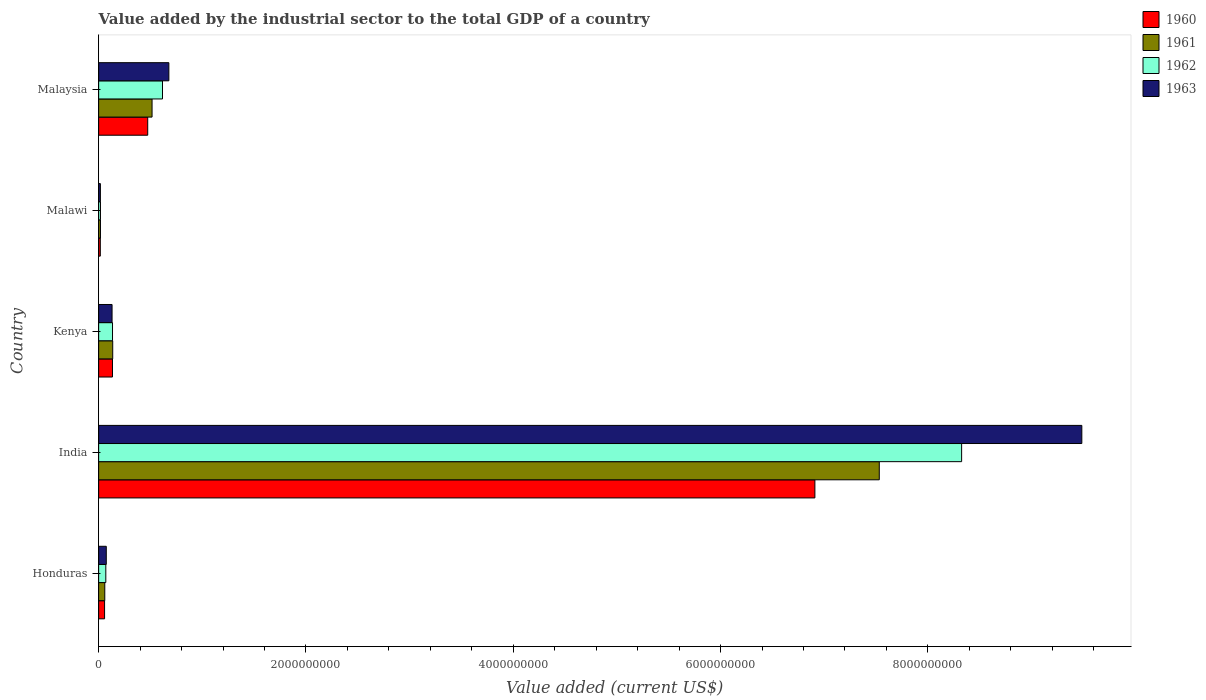How many different coloured bars are there?
Make the answer very short. 4. How many groups of bars are there?
Offer a very short reply. 5. How many bars are there on the 1st tick from the bottom?
Give a very brief answer. 4. What is the label of the 3rd group of bars from the top?
Your response must be concise. Kenya. What is the value added by the industrial sector to the total GDP in 1961 in India?
Your answer should be very brief. 7.53e+09. Across all countries, what is the maximum value added by the industrial sector to the total GDP in 1962?
Provide a succinct answer. 8.33e+09. Across all countries, what is the minimum value added by the industrial sector to the total GDP in 1960?
Make the answer very short. 1.62e+07. In which country was the value added by the industrial sector to the total GDP in 1962 minimum?
Offer a terse response. Malawi. What is the total value added by the industrial sector to the total GDP in 1962 in the graph?
Give a very brief answer. 9.16e+09. What is the difference between the value added by the industrial sector to the total GDP in 1962 in India and that in Kenya?
Offer a very short reply. 8.19e+09. What is the difference between the value added by the industrial sector to the total GDP in 1962 in India and the value added by the industrial sector to the total GDP in 1960 in Malawi?
Offer a very short reply. 8.31e+09. What is the average value added by the industrial sector to the total GDP in 1960 per country?
Give a very brief answer. 1.52e+09. What is the difference between the value added by the industrial sector to the total GDP in 1963 and value added by the industrial sector to the total GDP in 1961 in Honduras?
Ensure brevity in your answer.  1.44e+07. In how many countries, is the value added by the industrial sector to the total GDP in 1961 greater than 6000000000 US$?
Keep it short and to the point. 1. What is the ratio of the value added by the industrial sector to the total GDP in 1961 in Kenya to that in Malaysia?
Provide a succinct answer. 0.26. Is the value added by the industrial sector to the total GDP in 1962 in Honduras less than that in India?
Provide a short and direct response. Yes. Is the difference between the value added by the industrial sector to the total GDP in 1963 in Honduras and Malaysia greater than the difference between the value added by the industrial sector to the total GDP in 1961 in Honduras and Malaysia?
Your response must be concise. No. What is the difference between the highest and the second highest value added by the industrial sector to the total GDP in 1960?
Your response must be concise. 6.44e+09. What is the difference between the highest and the lowest value added by the industrial sector to the total GDP in 1963?
Offer a very short reply. 9.47e+09. What does the 4th bar from the bottom in Malaysia represents?
Offer a terse response. 1963. How many countries are there in the graph?
Ensure brevity in your answer.  5. Are the values on the major ticks of X-axis written in scientific E-notation?
Your answer should be very brief. No. Does the graph contain any zero values?
Provide a short and direct response. No. Does the graph contain grids?
Ensure brevity in your answer.  No. Where does the legend appear in the graph?
Make the answer very short. Top right. How many legend labels are there?
Provide a succinct answer. 4. How are the legend labels stacked?
Offer a terse response. Vertical. What is the title of the graph?
Make the answer very short. Value added by the industrial sector to the total GDP of a country. Does "2001" appear as one of the legend labels in the graph?
Offer a very short reply. No. What is the label or title of the X-axis?
Your response must be concise. Value added (current US$). What is the label or title of the Y-axis?
Provide a short and direct response. Country. What is the Value added (current US$) of 1960 in Honduras?
Ensure brevity in your answer.  5.73e+07. What is the Value added (current US$) of 1961 in Honduras?
Your answer should be compact. 5.94e+07. What is the Value added (current US$) of 1962 in Honduras?
Provide a short and direct response. 6.92e+07. What is the Value added (current US$) in 1963 in Honduras?
Offer a very short reply. 7.38e+07. What is the Value added (current US$) in 1960 in India?
Offer a terse response. 6.91e+09. What is the Value added (current US$) of 1961 in India?
Offer a terse response. 7.53e+09. What is the Value added (current US$) in 1962 in India?
Provide a succinct answer. 8.33e+09. What is the Value added (current US$) in 1963 in India?
Your response must be concise. 9.49e+09. What is the Value added (current US$) of 1960 in Kenya?
Ensure brevity in your answer.  1.34e+08. What is the Value added (current US$) in 1961 in Kenya?
Your response must be concise. 1.36e+08. What is the Value added (current US$) in 1962 in Kenya?
Keep it short and to the point. 1.34e+08. What is the Value added (current US$) of 1963 in Kenya?
Provide a succinct answer. 1.30e+08. What is the Value added (current US$) of 1960 in Malawi?
Your answer should be compact. 1.62e+07. What is the Value added (current US$) of 1961 in Malawi?
Provide a succinct answer. 1.76e+07. What is the Value added (current US$) of 1962 in Malawi?
Provide a succinct answer. 1.78e+07. What is the Value added (current US$) in 1963 in Malawi?
Your answer should be compact. 1.69e+07. What is the Value added (current US$) of 1960 in Malaysia?
Your answer should be very brief. 4.74e+08. What is the Value added (current US$) in 1961 in Malaysia?
Offer a very short reply. 5.15e+08. What is the Value added (current US$) in 1962 in Malaysia?
Ensure brevity in your answer.  6.16e+08. What is the Value added (current US$) in 1963 in Malaysia?
Ensure brevity in your answer.  6.77e+08. Across all countries, what is the maximum Value added (current US$) of 1960?
Ensure brevity in your answer.  6.91e+09. Across all countries, what is the maximum Value added (current US$) in 1961?
Your answer should be very brief. 7.53e+09. Across all countries, what is the maximum Value added (current US$) in 1962?
Make the answer very short. 8.33e+09. Across all countries, what is the maximum Value added (current US$) of 1963?
Your answer should be very brief. 9.49e+09. Across all countries, what is the minimum Value added (current US$) of 1960?
Provide a succinct answer. 1.62e+07. Across all countries, what is the minimum Value added (current US$) in 1961?
Your response must be concise. 1.76e+07. Across all countries, what is the minimum Value added (current US$) in 1962?
Provide a succinct answer. 1.78e+07. Across all countries, what is the minimum Value added (current US$) of 1963?
Your answer should be very brief. 1.69e+07. What is the total Value added (current US$) in 1960 in the graph?
Offer a terse response. 7.59e+09. What is the total Value added (current US$) in 1961 in the graph?
Ensure brevity in your answer.  8.26e+09. What is the total Value added (current US$) in 1962 in the graph?
Provide a succinct answer. 9.16e+09. What is the total Value added (current US$) of 1963 in the graph?
Provide a short and direct response. 1.04e+1. What is the difference between the Value added (current US$) in 1960 in Honduras and that in India?
Your answer should be compact. -6.85e+09. What is the difference between the Value added (current US$) of 1961 in Honduras and that in India?
Your response must be concise. -7.47e+09. What is the difference between the Value added (current US$) in 1962 in Honduras and that in India?
Keep it short and to the point. -8.26e+09. What is the difference between the Value added (current US$) in 1963 in Honduras and that in India?
Your answer should be very brief. -9.41e+09. What is the difference between the Value added (current US$) in 1960 in Honduras and that in Kenya?
Give a very brief answer. -7.63e+07. What is the difference between the Value added (current US$) of 1961 in Honduras and that in Kenya?
Your answer should be compact. -7.65e+07. What is the difference between the Value added (current US$) of 1962 in Honduras and that in Kenya?
Offer a very short reply. -6.47e+07. What is the difference between the Value added (current US$) of 1963 in Honduras and that in Kenya?
Provide a short and direct response. -5.57e+07. What is the difference between the Value added (current US$) in 1960 in Honduras and that in Malawi?
Offer a very short reply. 4.11e+07. What is the difference between the Value added (current US$) in 1961 in Honduras and that in Malawi?
Your response must be concise. 4.17e+07. What is the difference between the Value added (current US$) of 1962 in Honduras and that in Malawi?
Provide a short and direct response. 5.14e+07. What is the difference between the Value added (current US$) in 1963 in Honduras and that in Malawi?
Offer a terse response. 5.69e+07. What is the difference between the Value added (current US$) of 1960 in Honduras and that in Malaysia?
Keep it short and to the point. -4.16e+08. What is the difference between the Value added (current US$) of 1961 in Honduras and that in Malaysia?
Give a very brief answer. -4.56e+08. What is the difference between the Value added (current US$) of 1962 in Honduras and that in Malaysia?
Ensure brevity in your answer.  -5.47e+08. What is the difference between the Value added (current US$) in 1963 in Honduras and that in Malaysia?
Provide a short and direct response. -6.04e+08. What is the difference between the Value added (current US$) of 1960 in India and that in Kenya?
Keep it short and to the point. 6.78e+09. What is the difference between the Value added (current US$) of 1961 in India and that in Kenya?
Provide a succinct answer. 7.40e+09. What is the difference between the Value added (current US$) of 1962 in India and that in Kenya?
Offer a very short reply. 8.19e+09. What is the difference between the Value added (current US$) of 1963 in India and that in Kenya?
Offer a terse response. 9.36e+09. What is the difference between the Value added (current US$) of 1960 in India and that in Malawi?
Give a very brief answer. 6.89e+09. What is the difference between the Value added (current US$) of 1961 in India and that in Malawi?
Give a very brief answer. 7.51e+09. What is the difference between the Value added (current US$) of 1962 in India and that in Malawi?
Your answer should be compact. 8.31e+09. What is the difference between the Value added (current US$) in 1963 in India and that in Malawi?
Ensure brevity in your answer.  9.47e+09. What is the difference between the Value added (current US$) of 1960 in India and that in Malaysia?
Provide a succinct answer. 6.44e+09. What is the difference between the Value added (current US$) in 1961 in India and that in Malaysia?
Provide a succinct answer. 7.02e+09. What is the difference between the Value added (current US$) in 1962 in India and that in Malaysia?
Offer a very short reply. 7.71e+09. What is the difference between the Value added (current US$) in 1963 in India and that in Malaysia?
Provide a succinct answer. 8.81e+09. What is the difference between the Value added (current US$) of 1960 in Kenya and that in Malawi?
Ensure brevity in your answer.  1.17e+08. What is the difference between the Value added (current US$) in 1961 in Kenya and that in Malawi?
Make the answer very short. 1.18e+08. What is the difference between the Value added (current US$) of 1962 in Kenya and that in Malawi?
Ensure brevity in your answer.  1.16e+08. What is the difference between the Value added (current US$) in 1963 in Kenya and that in Malawi?
Provide a succinct answer. 1.13e+08. What is the difference between the Value added (current US$) of 1960 in Kenya and that in Malaysia?
Offer a terse response. -3.40e+08. What is the difference between the Value added (current US$) of 1961 in Kenya and that in Malaysia?
Provide a succinct answer. -3.79e+08. What is the difference between the Value added (current US$) in 1962 in Kenya and that in Malaysia?
Ensure brevity in your answer.  -4.82e+08. What is the difference between the Value added (current US$) in 1963 in Kenya and that in Malaysia?
Offer a very short reply. -5.48e+08. What is the difference between the Value added (current US$) in 1960 in Malawi and that in Malaysia?
Your answer should be compact. -4.57e+08. What is the difference between the Value added (current US$) in 1961 in Malawi and that in Malaysia?
Keep it short and to the point. -4.98e+08. What is the difference between the Value added (current US$) in 1962 in Malawi and that in Malaysia?
Provide a short and direct response. -5.98e+08. What is the difference between the Value added (current US$) in 1963 in Malawi and that in Malaysia?
Your answer should be compact. -6.61e+08. What is the difference between the Value added (current US$) in 1960 in Honduras and the Value added (current US$) in 1961 in India?
Offer a very short reply. -7.47e+09. What is the difference between the Value added (current US$) in 1960 in Honduras and the Value added (current US$) in 1962 in India?
Your response must be concise. -8.27e+09. What is the difference between the Value added (current US$) of 1960 in Honduras and the Value added (current US$) of 1963 in India?
Offer a very short reply. -9.43e+09. What is the difference between the Value added (current US$) of 1961 in Honduras and the Value added (current US$) of 1962 in India?
Your response must be concise. -8.27e+09. What is the difference between the Value added (current US$) of 1961 in Honduras and the Value added (current US$) of 1963 in India?
Your answer should be compact. -9.43e+09. What is the difference between the Value added (current US$) of 1962 in Honduras and the Value added (current US$) of 1963 in India?
Provide a succinct answer. -9.42e+09. What is the difference between the Value added (current US$) of 1960 in Honduras and the Value added (current US$) of 1961 in Kenya?
Your answer should be compact. -7.86e+07. What is the difference between the Value added (current US$) of 1960 in Honduras and the Value added (current US$) of 1962 in Kenya?
Make the answer very short. -7.66e+07. What is the difference between the Value added (current US$) of 1960 in Honduras and the Value added (current US$) of 1963 in Kenya?
Make the answer very short. -7.22e+07. What is the difference between the Value added (current US$) of 1961 in Honduras and the Value added (current US$) of 1962 in Kenya?
Keep it short and to the point. -7.46e+07. What is the difference between the Value added (current US$) of 1961 in Honduras and the Value added (current US$) of 1963 in Kenya?
Ensure brevity in your answer.  -7.02e+07. What is the difference between the Value added (current US$) in 1962 in Honduras and the Value added (current US$) in 1963 in Kenya?
Your answer should be very brief. -6.03e+07. What is the difference between the Value added (current US$) in 1960 in Honduras and the Value added (current US$) in 1961 in Malawi?
Your response must be concise. 3.97e+07. What is the difference between the Value added (current US$) of 1960 in Honduras and the Value added (current US$) of 1962 in Malawi?
Provide a succinct answer. 3.95e+07. What is the difference between the Value added (current US$) of 1960 in Honduras and the Value added (current US$) of 1963 in Malawi?
Your answer should be compact. 4.04e+07. What is the difference between the Value added (current US$) of 1961 in Honduras and the Value added (current US$) of 1962 in Malawi?
Keep it short and to the point. 4.16e+07. What is the difference between the Value added (current US$) in 1961 in Honduras and the Value added (current US$) in 1963 in Malawi?
Your response must be concise. 4.24e+07. What is the difference between the Value added (current US$) in 1962 in Honduras and the Value added (current US$) in 1963 in Malawi?
Your answer should be compact. 5.23e+07. What is the difference between the Value added (current US$) of 1960 in Honduras and the Value added (current US$) of 1961 in Malaysia?
Ensure brevity in your answer.  -4.58e+08. What is the difference between the Value added (current US$) in 1960 in Honduras and the Value added (current US$) in 1962 in Malaysia?
Your answer should be very brief. -5.59e+08. What is the difference between the Value added (current US$) of 1960 in Honduras and the Value added (current US$) of 1963 in Malaysia?
Offer a very short reply. -6.20e+08. What is the difference between the Value added (current US$) of 1961 in Honduras and the Value added (current US$) of 1962 in Malaysia?
Keep it short and to the point. -5.57e+08. What is the difference between the Value added (current US$) in 1961 in Honduras and the Value added (current US$) in 1963 in Malaysia?
Offer a very short reply. -6.18e+08. What is the difference between the Value added (current US$) of 1962 in Honduras and the Value added (current US$) of 1963 in Malaysia?
Provide a short and direct response. -6.08e+08. What is the difference between the Value added (current US$) in 1960 in India and the Value added (current US$) in 1961 in Kenya?
Your answer should be compact. 6.77e+09. What is the difference between the Value added (current US$) in 1960 in India and the Value added (current US$) in 1962 in Kenya?
Keep it short and to the point. 6.78e+09. What is the difference between the Value added (current US$) of 1960 in India and the Value added (current US$) of 1963 in Kenya?
Make the answer very short. 6.78e+09. What is the difference between the Value added (current US$) in 1961 in India and the Value added (current US$) in 1962 in Kenya?
Provide a succinct answer. 7.40e+09. What is the difference between the Value added (current US$) in 1961 in India and the Value added (current US$) in 1963 in Kenya?
Keep it short and to the point. 7.40e+09. What is the difference between the Value added (current US$) in 1962 in India and the Value added (current US$) in 1963 in Kenya?
Keep it short and to the point. 8.20e+09. What is the difference between the Value added (current US$) in 1960 in India and the Value added (current US$) in 1961 in Malawi?
Offer a very short reply. 6.89e+09. What is the difference between the Value added (current US$) of 1960 in India and the Value added (current US$) of 1962 in Malawi?
Your response must be concise. 6.89e+09. What is the difference between the Value added (current US$) in 1960 in India and the Value added (current US$) in 1963 in Malawi?
Provide a short and direct response. 6.89e+09. What is the difference between the Value added (current US$) in 1961 in India and the Value added (current US$) in 1962 in Malawi?
Your answer should be compact. 7.51e+09. What is the difference between the Value added (current US$) of 1961 in India and the Value added (current US$) of 1963 in Malawi?
Your answer should be very brief. 7.51e+09. What is the difference between the Value added (current US$) in 1962 in India and the Value added (current US$) in 1963 in Malawi?
Your answer should be compact. 8.31e+09. What is the difference between the Value added (current US$) in 1960 in India and the Value added (current US$) in 1961 in Malaysia?
Keep it short and to the point. 6.39e+09. What is the difference between the Value added (current US$) in 1960 in India and the Value added (current US$) in 1962 in Malaysia?
Keep it short and to the point. 6.29e+09. What is the difference between the Value added (current US$) in 1960 in India and the Value added (current US$) in 1963 in Malaysia?
Provide a succinct answer. 6.23e+09. What is the difference between the Value added (current US$) in 1961 in India and the Value added (current US$) in 1962 in Malaysia?
Make the answer very short. 6.92e+09. What is the difference between the Value added (current US$) of 1961 in India and the Value added (current US$) of 1963 in Malaysia?
Ensure brevity in your answer.  6.85e+09. What is the difference between the Value added (current US$) of 1962 in India and the Value added (current US$) of 1963 in Malaysia?
Your answer should be very brief. 7.65e+09. What is the difference between the Value added (current US$) in 1960 in Kenya and the Value added (current US$) in 1961 in Malawi?
Make the answer very short. 1.16e+08. What is the difference between the Value added (current US$) in 1960 in Kenya and the Value added (current US$) in 1962 in Malawi?
Your answer should be compact. 1.16e+08. What is the difference between the Value added (current US$) in 1960 in Kenya and the Value added (current US$) in 1963 in Malawi?
Give a very brief answer. 1.17e+08. What is the difference between the Value added (current US$) in 1961 in Kenya and the Value added (current US$) in 1962 in Malawi?
Your answer should be very brief. 1.18e+08. What is the difference between the Value added (current US$) in 1961 in Kenya and the Value added (current US$) in 1963 in Malawi?
Ensure brevity in your answer.  1.19e+08. What is the difference between the Value added (current US$) of 1962 in Kenya and the Value added (current US$) of 1963 in Malawi?
Keep it short and to the point. 1.17e+08. What is the difference between the Value added (current US$) in 1960 in Kenya and the Value added (current US$) in 1961 in Malaysia?
Your answer should be compact. -3.82e+08. What is the difference between the Value added (current US$) of 1960 in Kenya and the Value added (current US$) of 1962 in Malaysia?
Ensure brevity in your answer.  -4.82e+08. What is the difference between the Value added (current US$) in 1960 in Kenya and the Value added (current US$) in 1963 in Malaysia?
Offer a very short reply. -5.44e+08. What is the difference between the Value added (current US$) in 1961 in Kenya and the Value added (current US$) in 1962 in Malaysia?
Give a very brief answer. -4.80e+08. What is the difference between the Value added (current US$) in 1961 in Kenya and the Value added (current US$) in 1963 in Malaysia?
Offer a terse response. -5.42e+08. What is the difference between the Value added (current US$) in 1962 in Kenya and the Value added (current US$) in 1963 in Malaysia?
Give a very brief answer. -5.44e+08. What is the difference between the Value added (current US$) of 1960 in Malawi and the Value added (current US$) of 1961 in Malaysia?
Provide a short and direct response. -4.99e+08. What is the difference between the Value added (current US$) of 1960 in Malawi and the Value added (current US$) of 1962 in Malaysia?
Your answer should be compact. -6.00e+08. What is the difference between the Value added (current US$) of 1960 in Malawi and the Value added (current US$) of 1963 in Malaysia?
Ensure brevity in your answer.  -6.61e+08. What is the difference between the Value added (current US$) of 1961 in Malawi and the Value added (current US$) of 1962 in Malaysia?
Keep it short and to the point. -5.98e+08. What is the difference between the Value added (current US$) of 1961 in Malawi and the Value added (current US$) of 1963 in Malaysia?
Provide a succinct answer. -6.60e+08. What is the difference between the Value added (current US$) of 1962 in Malawi and the Value added (current US$) of 1963 in Malaysia?
Give a very brief answer. -6.60e+08. What is the average Value added (current US$) in 1960 per country?
Your response must be concise. 1.52e+09. What is the average Value added (current US$) in 1961 per country?
Your answer should be very brief. 1.65e+09. What is the average Value added (current US$) in 1962 per country?
Your response must be concise. 1.83e+09. What is the average Value added (current US$) of 1963 per country?
Your answer should be compact. 2.08e+09. What is the difference between the Value added (current US$) in 1960 and Value added (current US$) in 1961 in Honduras?
Offer a terse response. -2.05e+06. What is the difference between the Value added (current US$) in 1960 and Value added (current US$) in 1962 in Honduras?
Keep it short and to the point. -1.19e+07. What is the difference between the Value added (current US$) of 1960 and Value added (current US$) of 1963 in Honduras?
Offer a terse response. -1.65e+07. What is the difference between the Value added (current US$) in 1961 and Value added (current US$) in 1962 in Honduras?
Your answer should be compact. -9.85e+06. What is the difference between the Value added (current US$) of 1961 and Value added (current US$) of 1963 in Honduras?
Provide a short and direct response. -1.44e+07. What is the difference between the Value added (current US$) in 1962 and Value added (current US$) in 1963 in Honduras?
Offer a terse response. -4.60e+06. What is the difference between the Value added (current US$) of 1960 and Value added (current US$) of 1961 in India?
Give a very brief answer. -6.21e+08. What is the difference between the Value added (current US$) in 1960 and Value added (current US$) in 1962 in India?
Your response must be concise. -1.42e+09. What is the difference between the Value added (current US$) of 1960 and Value added (current US$) of 1963 in India?
Your response must be concise. -2.58e+09. What is the difference between the Value added (current US$) of 1961 and Value added (current US$) of 1962 in India?
Your response must be concise. -7.94e+08. What is the difference between the Value added (current US$) in 1961 and Value added (current US$) in 1963 in India?
Give a very brief answer. -1.95e+09. What is the difference between the Value added (current US$) of 1962 and Value added (current US$) of 1963 in India?
Provide a succinct answer. -1.16e+09. What is the difference between the Value added (current US$) in 1960 and Value added (current US$) in 1961 in Kenya?
Your answer should be compact. -2.25e+06. What is the difference between the Value added (current US$) of 1960 and Value added (current US$) of 1962 in Kenya?
Ensure brevity in your answer.  -2.94e+05. What is the difference between the Value added (current US$) in 1960 and Value added (current US$) in 1963 in Kenya?
Give a very brief answer. 4.12e+06. What is the difference between the Value added (current US$) in 1961 and Value added (current US$) in 1962 in Kenya?
Provide a succinct answer. 1.96e+06. What is the difference between the Value added (current US$) of 1961 and Value added (current US$) of 1963 in Kenya?
Your answer should be compact. 6.37e+06. What is the difference between the Value added (current US$) in 1962 and Value added (current US$) in 1963 in Kenya?
Keep it short and to the point. 4.41e+06. What is the difference between the Value added (current US$) of 1960 and Value added (current US$) of 1961 in Malawi?
Offer a terse response. -1.40e+06. What is the difference between the Value added (current US$) of 1960 and Value added (current US$) of 1962 in Malawi?
Give a very brief answer. -1.54e+06. What is the difference between the Value added (current US$) in 1960 and Value added (current US$) in 1963 in Malawi?
Make the answer very short. -7.00e+05. What is the difference between the Value added (current US$) in 1961 and Value added (current US$) in 1962 in Malawi?
Make the answer very short. -1.40e+05. What is the difference between the Value added (current US$) of 1961 and Value added (current US$) of 1963 in Malawi?
Offer a very short reply. 7.00e+05. What is the difference between the Value added (current US$) in 1962 and Value added (current US$) in 1963 in Malawi?
Provide a succinct answer. 8.40e+05. What is the difference between the Value added (current US$) in 1960 and Value added (current US$) in 1961 in Malaysia?
Offer a very short reply. -4.19e+07. What is the difference between the Value added (current US$) in 1960 and Value added (current US$) in 1962 in Malaysia?
Provide a succinct answer. -1.43e+08. What is the difference between the Value added (current US$) of 1960 and Value added (current US$) of 1963 in Malaysia?
Provide a short and direct response. -2.04e+08. What is the difference between the Value added (current US$) in 1961 and Value added (current US$) in 1962 in Malaysia?
Ensure brevity in your answer.  -1.01e+08. What is the difference between the Value added (current US$) of 1961 and Value added (current US$) of 1963 in Malaysia?
Your answer should be very brief. -1.62e+08. What is the difference between the Value added (current US$) in 1962 and Value added (current US$) in 1963 in Malaysia?
Your answer should be compact. -6.14e+07. What is the ratio of the Value added (current US$) in 1960 in Honduras to that in India?
Keep it short and to the point. 0.01. What is the ratio of the Value added (current US$) in 1961 in Honduras to that in India?
Give a very brief answer. 0.01. What is the ratio of the Value added (current US$) in 1962 in Honduras to that in India?
Make the answer very short. 0.01. What is the ratio of the Value added (current US$) in 1963 in Honduras to that in India?
Your answer should be compact. 0.01. What is the ratio of the Value added (current US$) of 1960 in Honduras to that in Kenya?
Offer a terse response. 0.43. What is the ratio of the Value added (current US$) in 1961 in Honduras to that in Kenya?
Your response must be concise. 0.44. What is the ratio of the Value added (current US$) in 1962 in Honduras to that in Kenya?
Give a very brief answer. 0.52. What is the ratio of the Value added (current US$) of 1963 in Honduras to that in Kenya?
Your response must be concise. 0.57. What is the ratio of the Value added (current US$) in 1960 in Honduras to that in Malawi?
Offer a very short reply. 3.53. What is the ratio of the Value added (current US$) in 1961 in Honduras to that in Malawi?
Offer a terse response. 3.36. What is the ratio of the Value added (current US$) of 1962 in Honduras to that in Malawi?
Offer a terse response. 3.89. What is the ratio of the Value added (current US$) in 1963 in Honduras to that in Malawi?
Keep it short and to the point. 4.36. What is the ratio of the Value added (current US$) of 1960 in Honduras to that in Malaysia?
Make the answer very short. 0.12. What is the ratio of the Value added (current US$) in 1961 in Honduras to that in Malaysia?
Make the answer very short. 0.12. What is the ratio of the Value added (current US$) of 1962 in Honduras to that in Malaysia?
Keep it short and to the point. 0.11. What is the ratio of the Value added (current US$) in 1963 in Honduras to that in Malaysia?
Your response must be concise. 0.11. What is the ratio of the Value added (current US$) of 1960 in India to that in Kenya?
Offer a terse response. 51.7. What is the ratio of the Value added (current US$) in 1961 in India to that in Kenya?
Provide a short and direct response. 55.42. What is the ratio of the Value added (current US$) of 1962 in India to that in Kenya?
Offer a terse response. 62.16. What is the ratio of the Value added (current US$) of 1963 in India to that in Kenya?
Your answer should be very brief. 73.23. What is the ratio of the Value added (current US$) of 1960 in India to that in Malawi?
Provide a succinct answer. 425.49. What is the ratio of the Value added (current US$) in 1961 in India to that in Malawi?
Keep it short and to the point. 426.94. What is the ratio of the Value added (current US$) in 1962 in India to that in Malawi?
Provide a succinct answer. 468.26. What is the ratio of the Value added (current US$) in 1963 in India to that in Malawi?
Give a very brief answer. 559.94. What is the ratio of the Value added (current US$) of 1960 in India to that in Malaysia?
Your answer should be very brief. 14.59. What is the ratio of the Value added (current US$) of 1961 in India to that in Malaysia?
Your response must be concise. 14.61. What is the ratio of the Value added (current US$) in 1962 in India to that in Malaysia?
Provide a short and direct response. 13.51. What is the ratio of the Value added (current US$) of 1963 in India to that in Malaysia?
Your answer should be compact. 14. What is the ratio of the Value added (current US$) in 1960 in Kenya to that in Malawi?
Your answer should be very brief. 8.23. What is the ratio of the Value added (current US$) of 1961 in Kenya to that in Malawi?
Offer a very short reply. 7.7. What is the ratio of the Value added (current US$) in 1962 in Kenya to that in Malawi?
Offer a very short reply. 7.53. What is the ratio of the Value added (current US$) in 1963 in Kenya to that in Malawi?
Your response must be concise. 7.65. What is the ratio of the Value added (current US$) in 1960 in Kenya to that in Malaysia?
Make the answer very short. 0.28. What is the ratio of the Value added (current US$) of 1961 in Kenya to that in Malaysia?
Your answer should be very brief. 0.26. What is the ratio of the Value added (current US$) of 1962 in Kenya to that in Malaysia?
Provide a succinct answer. 0.22. What is the ratio of the Value added (current US$) of 1963 in Kenya to that in Malaysia?
Offer a terse response. 0.19. What is the ratio of the Value added (current US$) in 1960 in Malawi to that in Malaysia?
Your answer should be very brief. 0.03. What is the ratio of the Value added (current US$) in 1961 in Malawi to that in Malaysia?
Provide a succinct answer. 0.03. What is the ratio of the Value added (current US$) in 1962 in Malawi to that in Malaysia?
Keep it short and to the point. 0.03. What is the ratio of the Value added (current US$) of 1963 in Malawi to that in Malaysia?
Make the answer very short. 0.03. What is the difference between the highest and the second highest Value added (current US$) of 1960?
Ensure brevity in your answer.  6.44e+09. What is the difference between the highest and the second highest Value added (current US$) of 1961?
Your response must be concise. 7.02e+09. What is the difference between the highest and the second highest Value added (current US$) of 1962?
Your response must be concise. 7.71e+09. What is the difference between the highest and the second highest Value added (current US$) in 1963?
Offer a very short reply. 8.81e+09. What is the difference between the highest and the lowest Value added (current US$) in 1960?
Give a very brief answer. 6.89e+09. What is the difference between the highest and the lowest Value added (current US$) in 1961?
Give a very brief answer. 7.51e+09. What is the difference between the highest and the lowest Value added (current US$) in 1962?
Give a very brief answer. 8.31e+09. What is the difference between the highest and the lowest Value added (current US$) in 1963?
Give a very brief answer. 9.47e+09. 